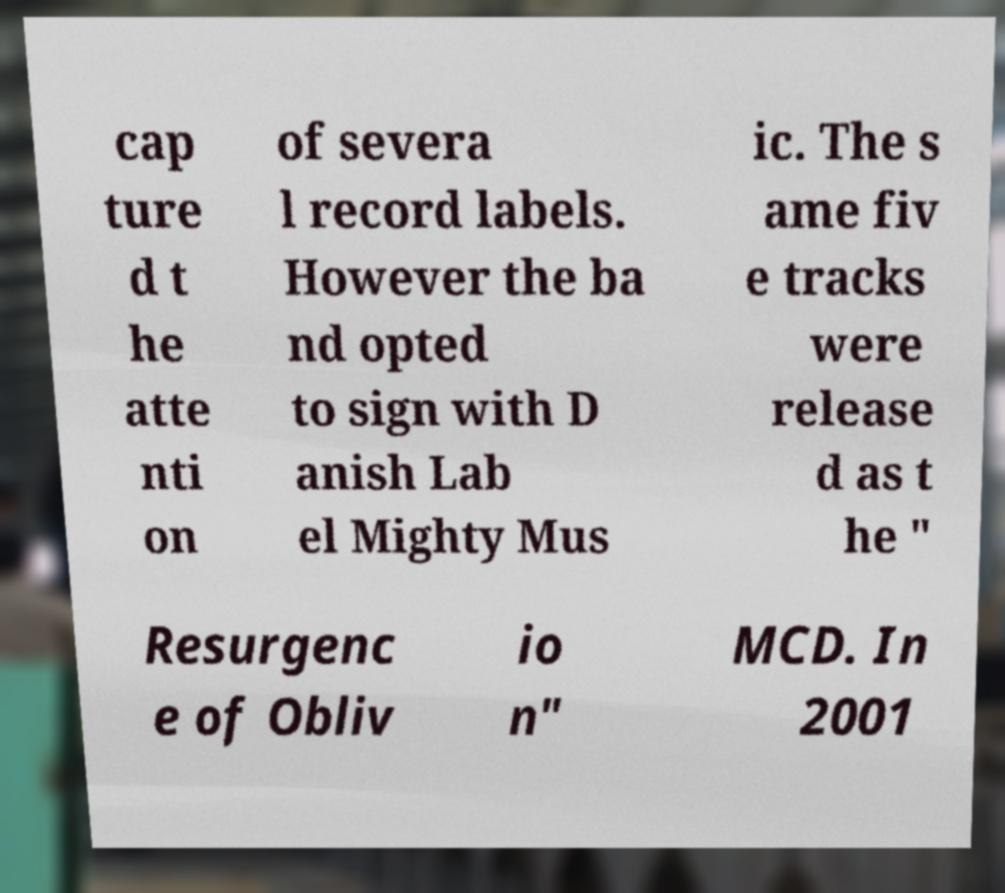Please read and relay the text visible in this image. What does it say? cap ture d t he atte nti on of severa l record labels. However the ba nd opted to sign with D anish Lab el Mighty Mus ic. The s ame fiv e tracks were release d as t he " Resurgenc e of Obliv io n" MCD. In 2001 